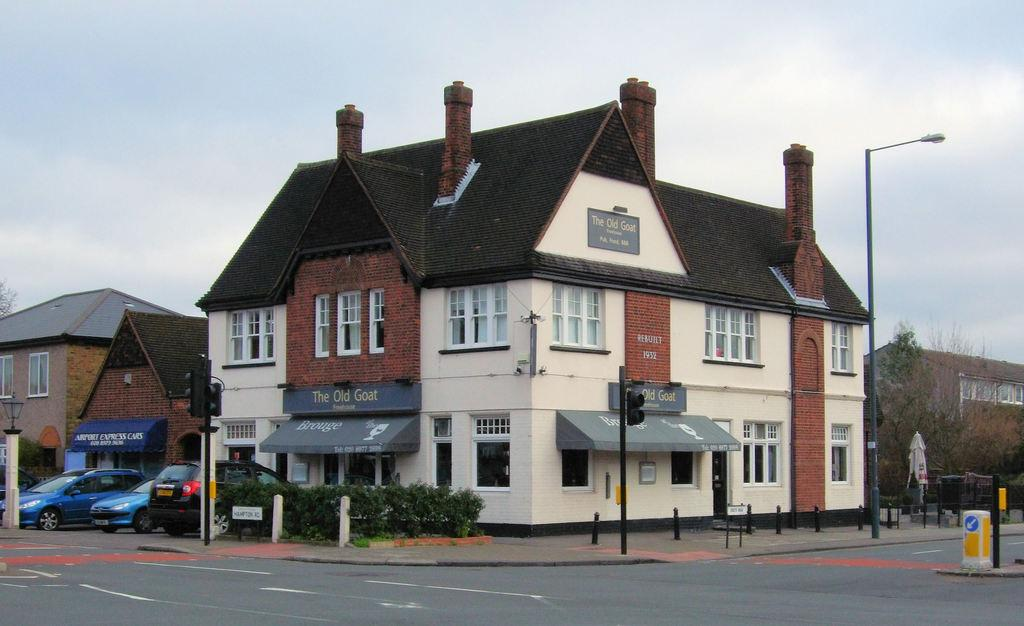What type of structures can be seen in the image? There are buildings in the image. What else is present near the buildings? There are vehicles near the buildings. What type of vegetation is visible in front of the buildings? There are trees in front of the buildings. Can you describe the other trees visible in the image? There are other trees visible in the image. Where is the building located in the image? There is a building in the right corner of the image. What type of interest does the basketball team have in the image? There is no basketball team or interest mentioned in the image; it features buildings, vehicles, and trees. 